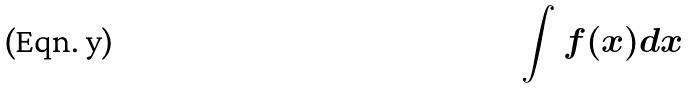Convert formula to latex. <formula><loc_0><loc_0><loc_500><loc_500>\int f ( x ) d x</formula> 